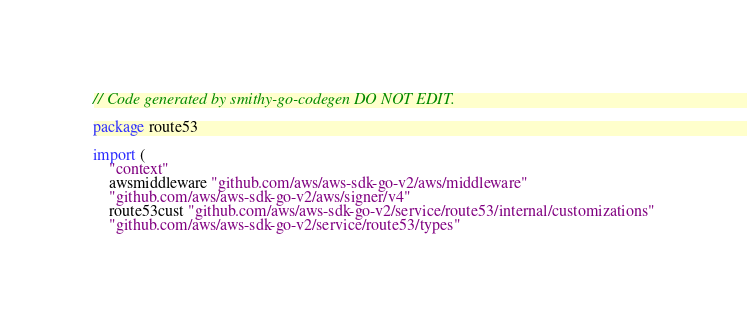<code> <loc_0><loc_0><loc_500><loc_500><_Go_>// Code generated by smithy-go-codegen DO NOT EDIT.

package route53

import (
	"context"
	awsmiddleware "github.com/aws/aws-sdk-go-v2/aws/middleware"
	"github.com/aws/aws-sdk-go-v2/aws/signer/v4"
	route53cust "github.com/aws/aws-sdk-go-v2/service/route53/internal/customizations"
	"github.com/aws/aws-sdk-go-v2/service/route53/types"</code> 